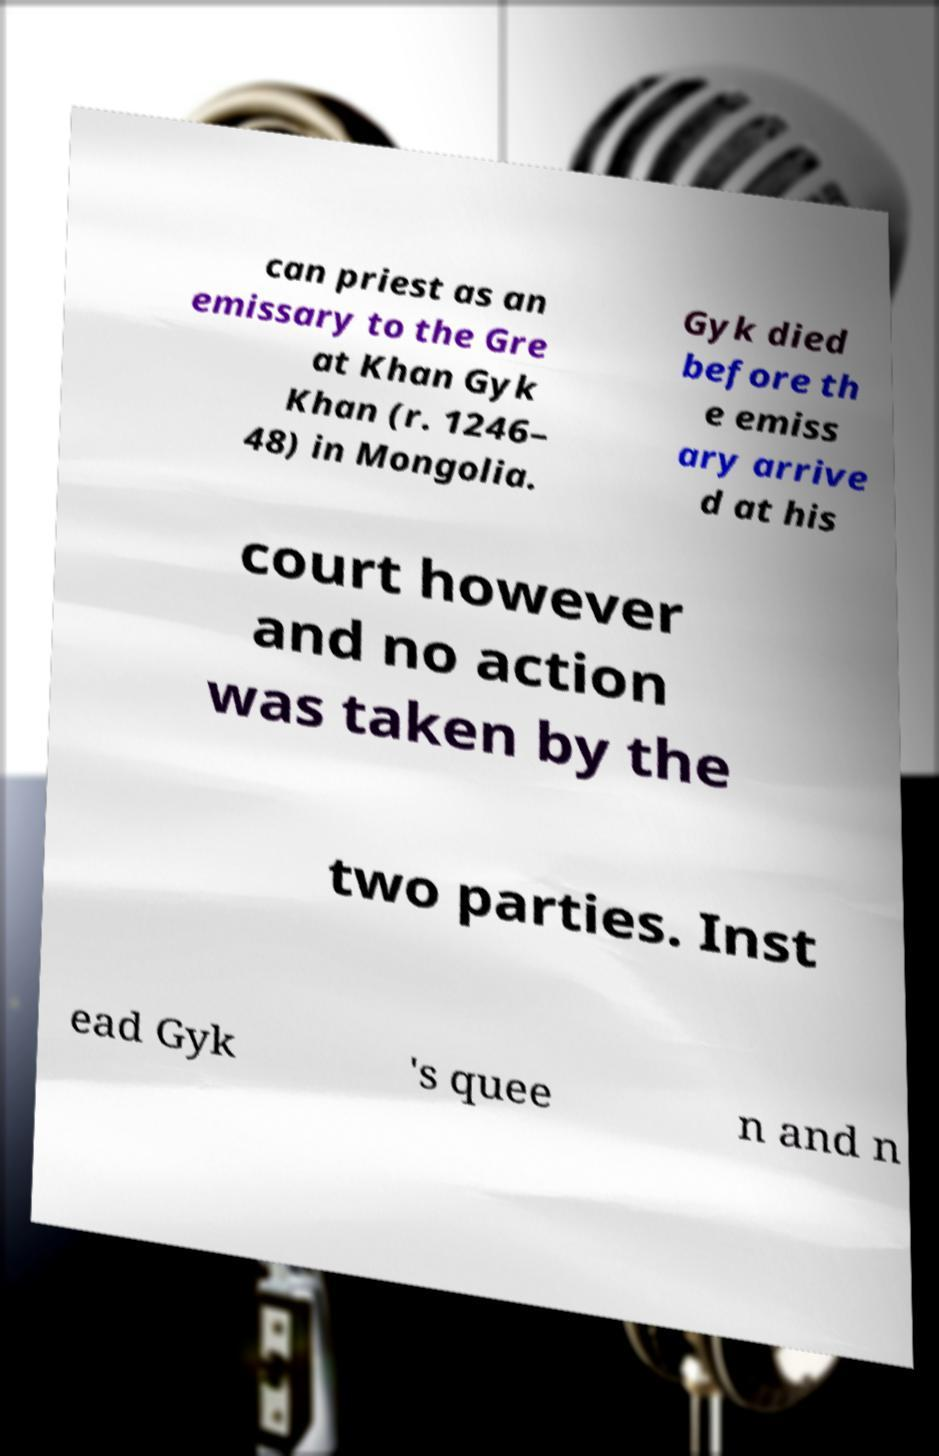Can you read and provide the text displayed in the image?This photo seems to have some interesting text. Can you extract and type it out for me? can priest as an emissary to the Gre at Khan Gyk Khan (r. 1246– 48) in Mongolia. Gyk died before th e emiss ary arrive d at his court however and no action was taken by the two parties. Inst ead Gyk 's quee n and n 